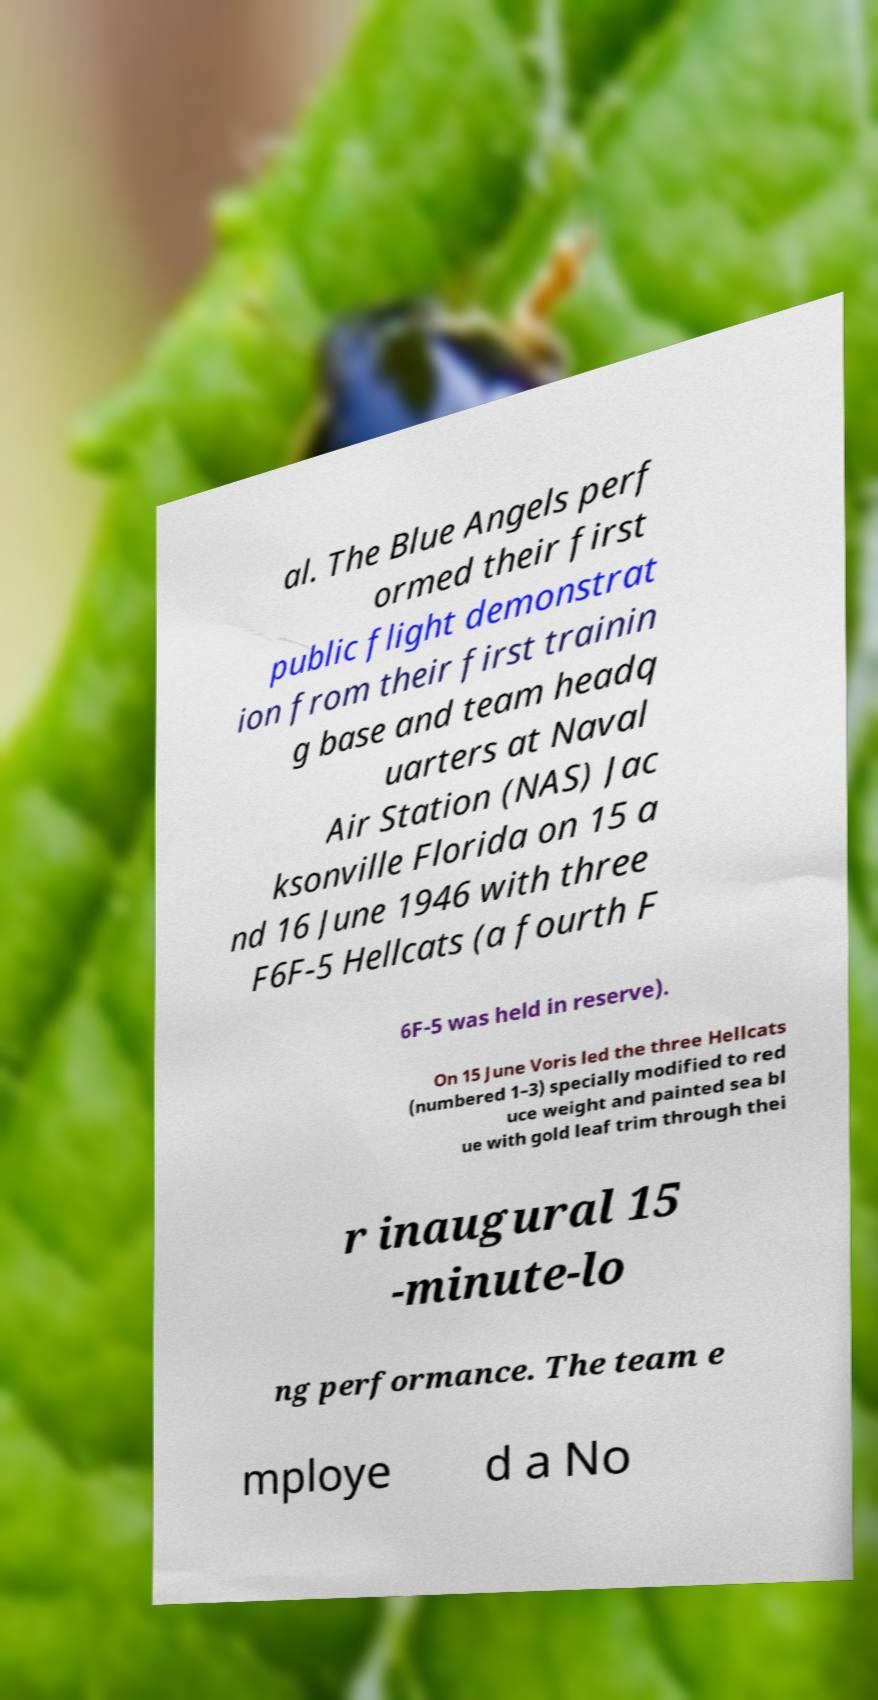Can you read and provide the text displayed in the image?This photo seems to have some interesting text. Can you extract and type it out for me? al. The Blue Angels perf ormed their first public flight demonstrat ion from their first trainin g base and team headq uarters at Naval Air Station (NAS) Jac ksonville Florida on 15 a nd 16 June 1946 with three F6F-5 Hellcats (a fourth F 6F-5 was held in reserve). On 15 June Voris led the three Hellcats (numbered 1–3) specially modified to red uce weight and painted sea bl ue with gold leaf trim through thei r inaugural 15 -minute-lo ng performance. The team e mploye d a No 